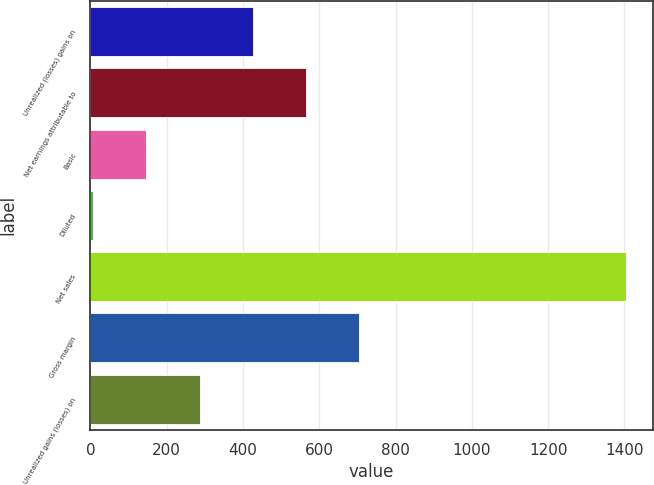<chart> <loc_0><loc_0><loc_500><loc_500><bar_chart><fcel>Unrealized (losses) gains on<fcel>Net earnings attributable to<fcel>Basic<fcel>Diluted<fcel>Net sales<fcel>Gross margin<fcel>Unrealized gains (losses) on<nl><fcel>425.58<fcel>565.33<fcel>146.09<fcel>6.35<fcel>1403.8<fcel>705.08<fcel>285.84<nl></chart> 